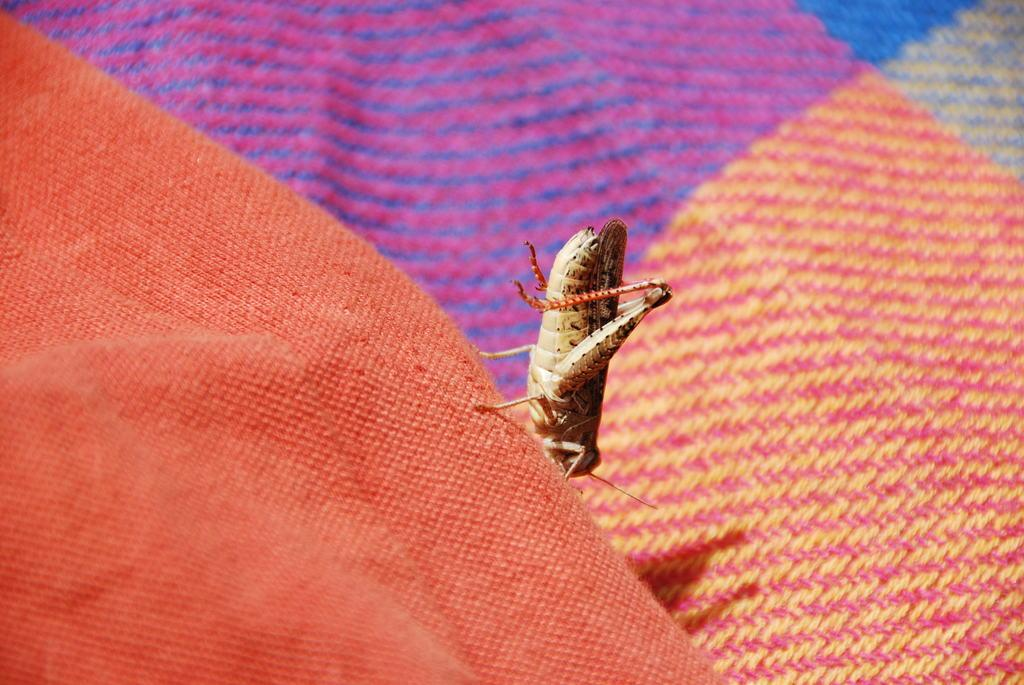What is present on the ground in the image? There is a mat in the image. What type of insect can be seen in the image? There is a grasshopper in the image. Is there a bridge visible in the image? No, there is no bridge present in the image. What type of plant can be seen in the image? There is no plant visible in the image, including a cactus. 